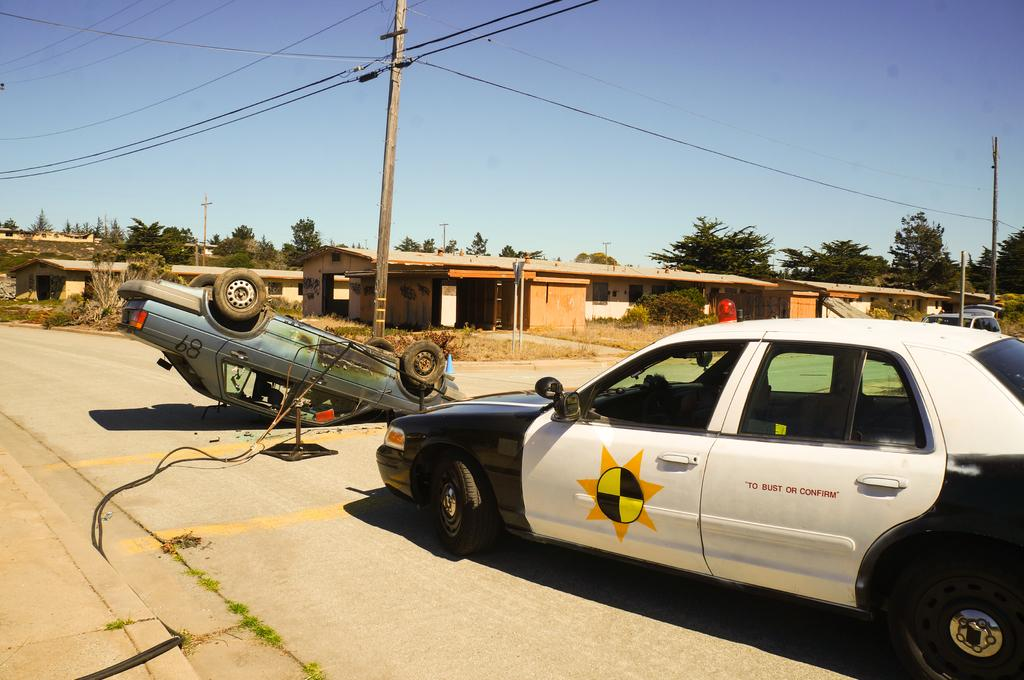<image>
Provide a brief description of the given image. Black and white vehicle that says "To bust of confirm" on it. 